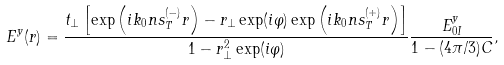<formula> <loc_0><loc_0><loc_500><loc_500>E ^ { y } ( { r } ) = \frac { t _ { \perp } \left [ \exp \left ( i k _ { 0 } n { s } _ { T } ^ { ( - ) } { r } \right ) - r _ { \perp } \exp ( i \varphi ) \exp \left ( i k _ { 0 } n { s } _ { T } ^ { ( + ) } { r } \right ) \right ] } { 1 - r _ { \perp } ^ { 2 } \exp ( i \varphi ) } \frac { E _ { 0 I } ^ { y } } { 1 - ( 4 \pi / 3 ) C } ,</formula> 